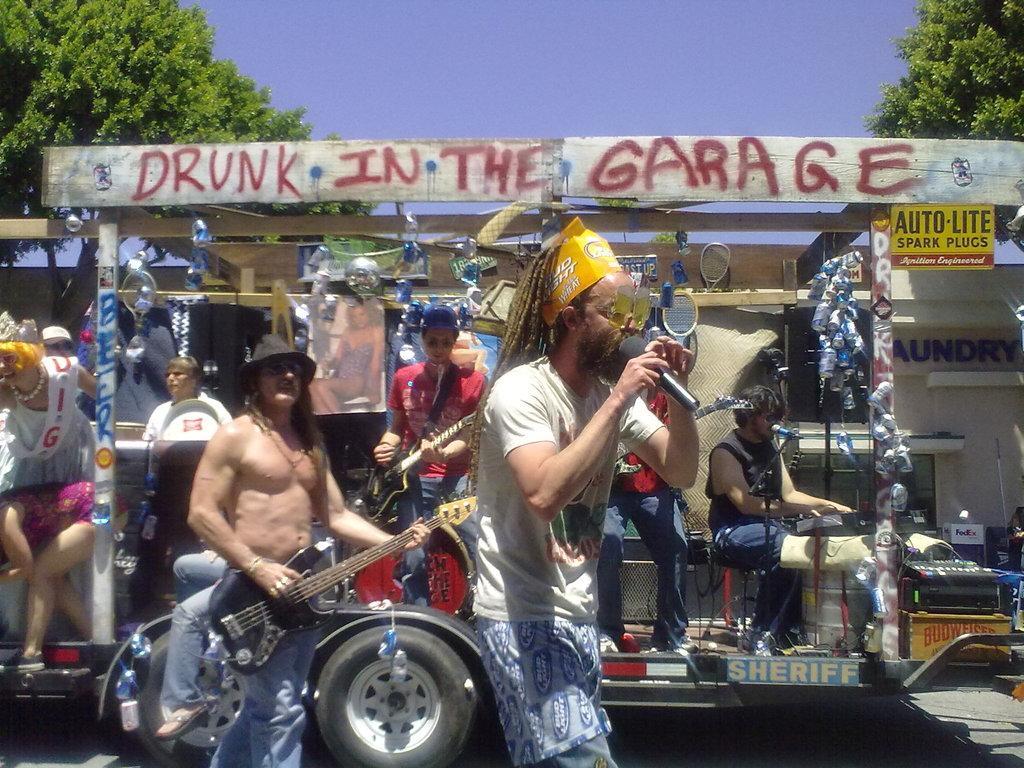In one or two sentences, can you explain what this image depicts? In this image in the middle there is a man standing and he is holding a microphone which is in black color, in the left side there is a man standing and holding a music instrument which is in black color. In the background there is a car in that there are some people sitting and there are some people standing, in the top there is a green color tree and there is a sky in blue color. 